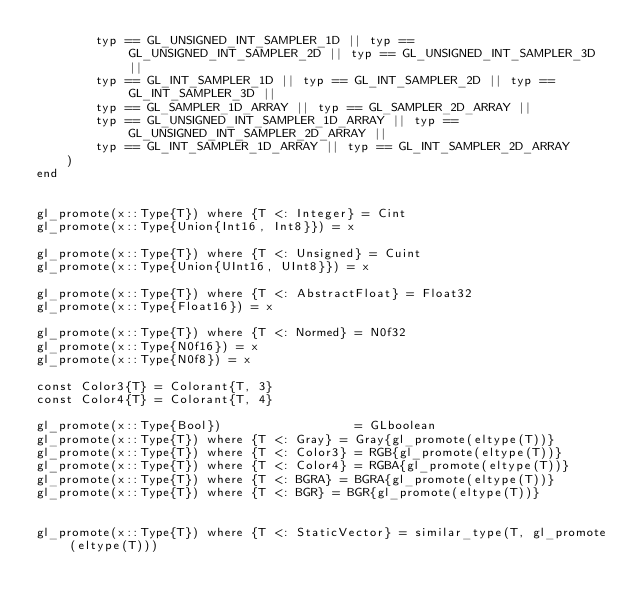Convert code to text. <code><loc_0><loc_0><loc_500><loc_500><_Julia_>        typ == GL_UNSIGNED_INT_SAMPLER_1D || typ == GL_UNSIGNED_INT_SAMPLER_2D || typ == GL_UNSIGNED_INT_SAMPLER_3D ||
        typ == GL_INT_SAMPLER_1D || typ == GL_INT_SAMPLER_2D || typ == GL_INT_SAMPLER_3D ||
        typ == GL_SAMPLER_1D_ARRAY || typ == GL_SAMPLER_2D_ARRAY ||
        typ == GL_UNSIGNED_INT_SAMPLER_1D_ARRAY || typ == GL_UNSIGNED_INT_SAMPLER_2D_ARRAY ||
        typ == GL_INT_SAMPLER_1D_ARRAY || typ == GL_INT_SAMPLER_2D_ARRAY
    )
end


gl_promote(x::Type{T}) where {T <: Integer} = Cint
gl_promote(x::Type{Union{Int16, Int8}}) = x

gl_promote(x::Type{T}) where {T <: Unsigned} = Cuint
gl_promote(x::Type{Union{UInt16, UInt8}}) = x

gl_promote(x::Type{T}) where {T <: AbstractFloat} = Float32
gl_promote(x::Type{Float16}) = x

gl_promote(x::Type{T}) where {T <: Normed} = N0f32
gl_promote(x::Type{N0f16}) = x
gl_promote(x::Type{N0f8}) = x

const Color3{T} = Colorant{T, 3}
const Color4{T} = Colorant{T, 4}

gl_promote(x::Type{Bool})                  = GLboolean
gl_promote(x::Type{T}) where {T <: Gray} = Gray{gl_promote(eltype(T))}
gl_promote(x::Type{T}) where {T <: Color3} = RGB{gl_promote(eltype(T))}
gl_promote(x::Type{T}) where {T <: Color4} = RGBA{gl_promote(eltype(T))}
gl_promote(x::Type{T}) where {T <: BGRA} = BGRA{gl_promote(eltype(T))}
gl_promote(x::Type{T}) where {T <: BGR} = BGR{gl_promote(eltype(T))}


gl_promote(x::Type{T}) where {T <: StaticVector} = similar_type(T, gl_promote(eltype(T)))
</code> 